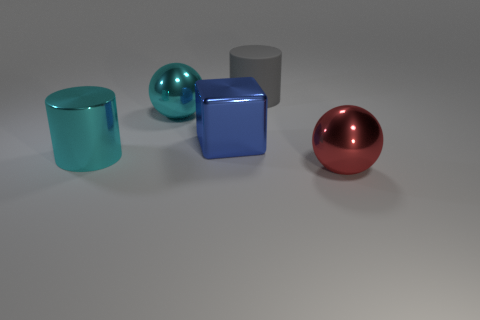Is the shape of the cyan shiny thing behind the big blue metallic thing the same as the big blue object? The cyan object is indeed shiny and shares a cylindrical shape like the big blue object, but they are not exactly the same. The cyan object appears to be a hollow cylinder with open ends, while the big blue metallic object is a solid cube. Hence, while both exhibit geometric properties and reflectivity, their specific shapes differ. 